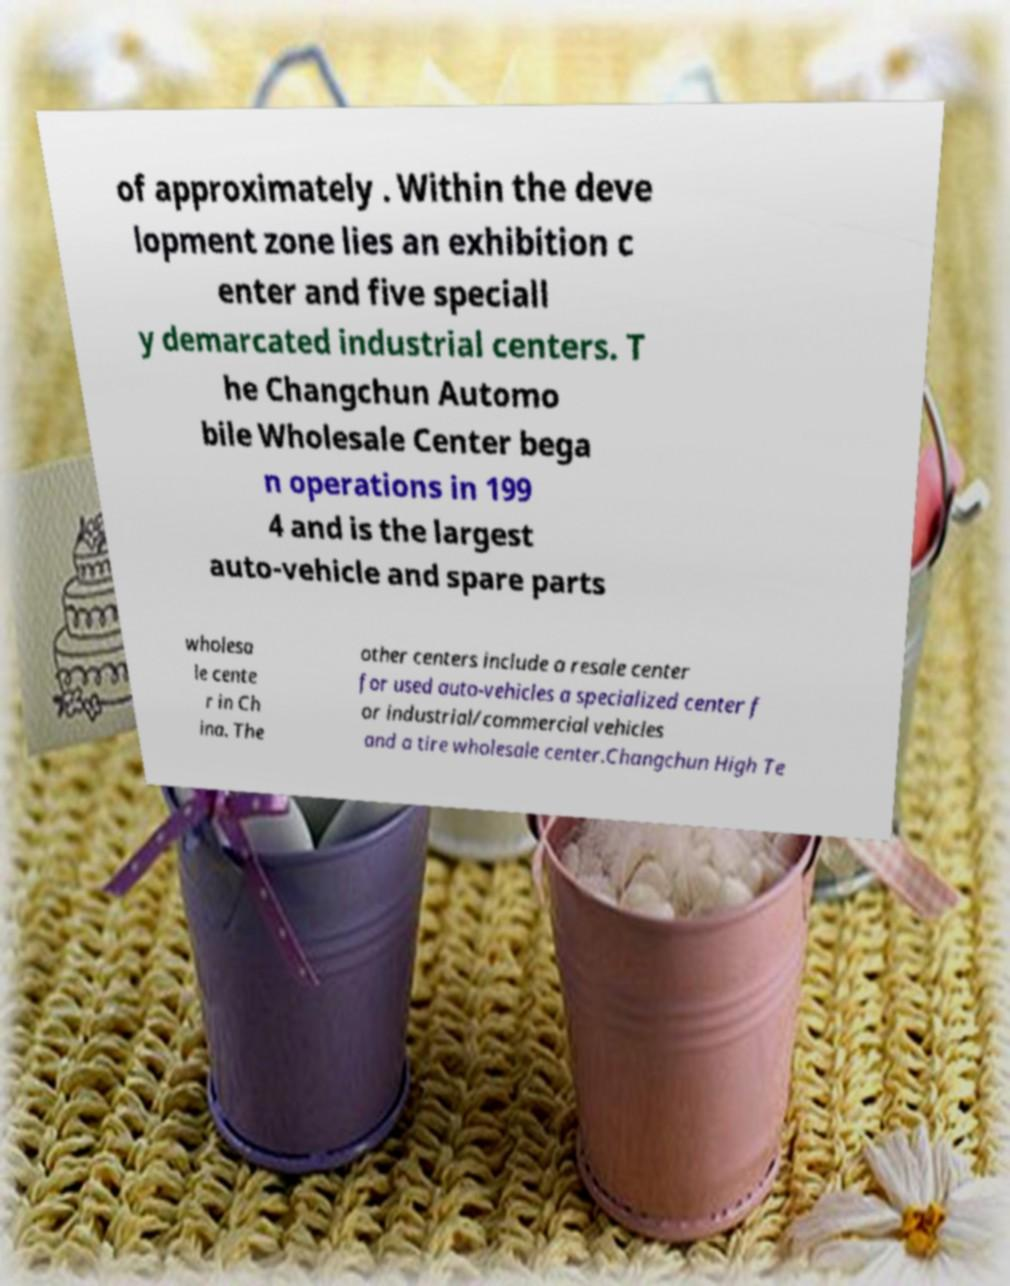For documentation purposes, I need the text within this image transcribed. Could you provide that? of approximately . Within the deve lopment zone lies an exhibition c enter and five speciall y demarcated industrial centers. T he Changchun Automo bile Wholesale Center bega n operations in 199 4 and is the largest auto-vehicle and spare parts wholesa le cente r in Ch ina. The other centers include a resale center for used auto-vehicles a specialized center f or industrial/commercial vehicles and a tire wholesale center.Changchun High Te 